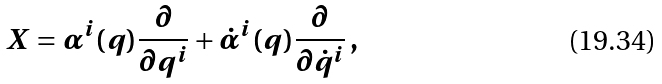<formula> <loc_0><loc_0><loc_500><loc_500>X = \alpha ^ { i } ( q ) \frac { \partial } { \partial q ^ { i } } + \dot { \alpha } ^ { i } ( q ) \frac { \partial } { \partial \dot { q } ^ { i } } \, { , }</formula> 